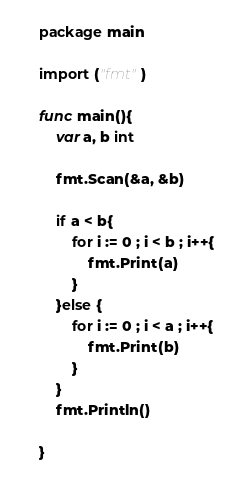<code> <loc_0><loc_0><loc_500><loc_500><_Go_>    package main
     
    import ("fmt")
     
    func main(){
    	var a, b int
     
    	fmt.Scan(&a, &b)
     
    	if a < b{
    		for i := 0 ; i < b ; i++{
    			fmt.Print(a)
    		}
    	}else {
    		for i := 0 ; i < a ; i++{
    			fmt.Print(b)
    		}
    	}
    	fmt.Println()
     
    }</code> 